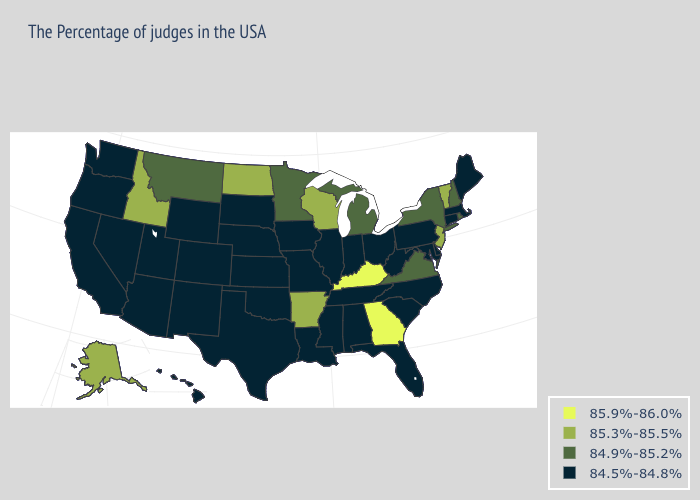What is the highest value in the USA?
Be succinct. 85.9%-86.0%. What is the lowest value in states that border North Dakota?
Write a very short answer. 84.5%-84.8%. Name the states that have a value in the range 85.9%-86.0%?
Give a very brief answer. Georgia, Kentucky. Name the states that have a value in the range 85.3%-85.5%?
Keep it brief. Vermont, New Jersey, Wisconsin, Arkansas, North Dakota, Idaho, Alaska. What is the value of Colorado?
Give a very brief answer. 84.5%-84.8%. Which states have the lowest value in the USA?
Write a very short answer. Maine, Massachusetts, Connecticut, Delaware, Maryland, Pennsylvania, North Carolina, South Carolina, West Virginia, Ohio, Florida, Indiana, Alabama, Tennessee, Illinois, Mississippi, Louisiana, Missouri, Iowa, Kansas, Nebraska, Oklahoma, Texas, South Dakota, Wyoming, Colorado, New Mexico, Utah, Arizona, Nevada, California, Washington, Oregon, Hawaii. What is the value of New Mexico?
Write a very short answer. 84.5%-84.8%. Does Pennsylvania have a higher value than Florida?
Answer briefly. No. What is the value of Washington?
Keep it brief. 84.5%-84.8%. Name the states that have a value in the range 85.3%-85.5%?
Concise answer only. Vermont, New Jersey, Wisconsin, Arkansas, North Dakota, Idaho, Alaska. What is the value of West Virginia?
Quick response, please. 84.5%-84.8%. Which states have the lowest value in the MidWest?
Write a very short answer. Ohio, Indiana, Illinois, Missouri, Iowa, Kansas, Nebraska, South Dakota. Name the states that have a value in the range 85.9%-86.0%?
Write a very short answer. Georgia, Kentucky. Which states have the lowest value in the USA?
Concise answer only. Maine, Massachusetts, Connecticut, Delaware, Maryland, Pennsylvania, North Carolina, South Carolina, West Virginia, Ohio, Florida, Indiana, Alabama, Tennessee, Illinois, Mississippi, Louisiana, Missouri, Iowa, Kansas, Nebraska, Oklahoma, Texas, South Dakota, Wyoming, Colorado, New Mexico, Utah, Arizona, Nevada, California, Washington, Oregon, Hawaii. Which states have the lowest value in the USA?
Be succinct. Maine, Massachusetts, Connecticut, Delaware, Maryland, Pennsylvania, North Carolina, South Carolina, West Virginia, Ohio, Florida, Indiana, Alabama, Tennessee, Illinois, Mississippi, Louisiana, Missouri, Iowa, Kansas, Nebraska, Oklahoma, Texas, South Dakota, Wyoming, Colorado, New Mexico, Utah, Arizona, Nevada, California, Washington, Oregon, Hawaii. 